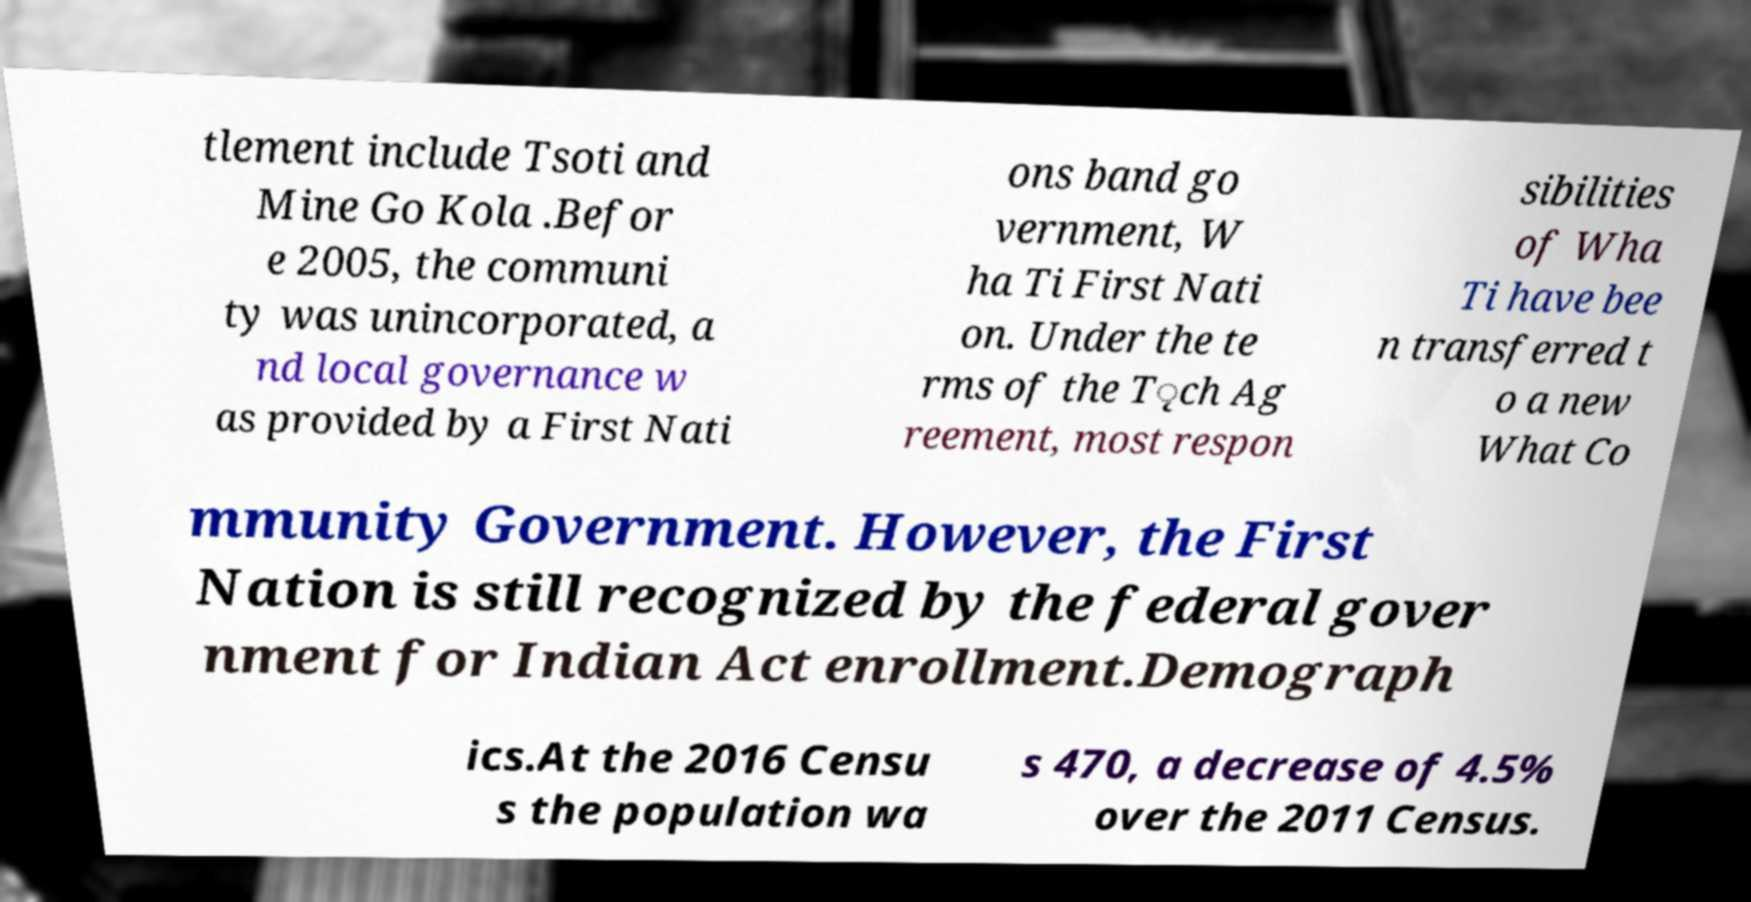I need the written content from this picture converted into text. Can you do that? tlement include Tsoti and Mine Go Kola .Befor e 2005, the communi ty was unincorporated, a nd local governance w as provided by a First Nati ons band go vernment, W ha Ti First Nati on. Under the te rms of the T̨ch Ag reement, most respon sibilities of Wha Ti have bee n transferred t o a new What Co mmunity Government. However, the First Nation is still recognized by the federal gover nment for Indian Act enrollment.Demograph ics.At the 2016 Censu s the population wa s 470, a decrease of 4.5% over the 2011 Census. 